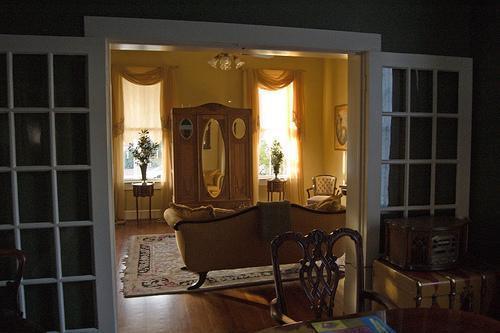How many rooms are in the picture?
Give a very brief answer. 2. 